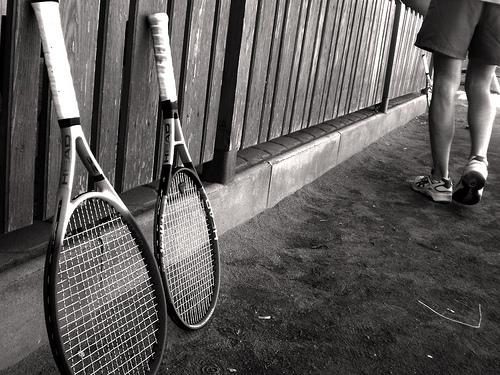Question: what kind of rackets are these?
Choices:
A. Racquetball.
B. Tennis rackets.
C. Lacrosse.
D. Badminton.
Answer with the letter. Answer: B Question: where are the tennis rackets?
Choices:
A. The table.
B. The chair.
C. Up against the wall.
D. The net.
Answer with the letter. Answer: C Question: what is the wall made of?
Choices:
A. Stucco.
B. Brick.
C. Wood.
D. Plaster.
Answer with the letter. Answer: C Question: what is the ground made of?
Choices:
A. Sand.
B. Mud.
C. Dirt.
D. Rocks.
Answer with the letter. Answer: C Question: what are the tennis rackets up against?
Choices:
A. The net.
B. The chair.
C. The wall.
D. The table.
Answer with the letter. Answer: C 